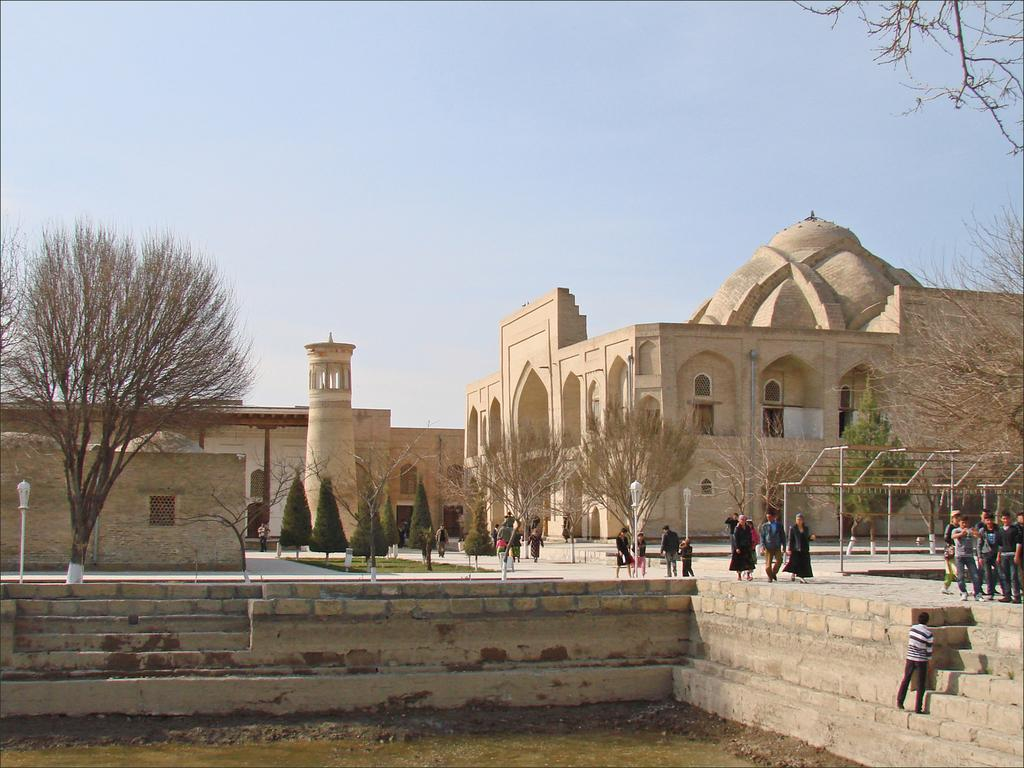What type of structure is present in the image? There is a brick wall with steps in the image. How many people are in the image? There are many people in the image. What other natural elements can be seen in the image? There are many trees in the image. What architectural features are present in the image? There are buildings with arches in the image. What can be seen in the background of the image? The sky is visible in the background of the image. How many visitors does the partner bring to the image? There is no mention of a partner or visitors in the image; it features a brick wall with steps, people, trees, buildings with arches, and the sky. 